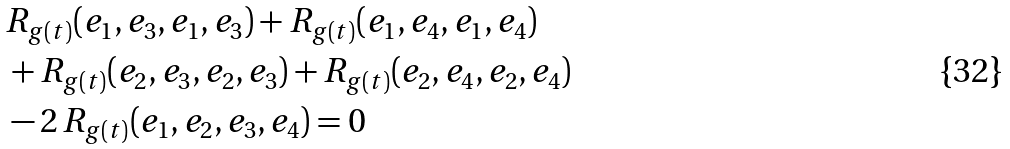Convert formula to latex. <formula><loc_0><loc_0><loc_500><loc_500>& R _ { g ( t ) } ( e _ { 1 } , e _ { 3 } , e _ { 1 } , e _ { 3 } ) + R _ { g ( t ) } ( e _ { 1 } , e _ { 4 } , e _ { 1 } , e _ { 4 } ) \\ & + R _ { g ( t ) } ( e _ { 2 } , e _ { 3 } , e _ { 2 } , e _ { 3 } ) + R _ { g ( t ) } ( e _ { 2 } , e _ { 4 } , e _ { 2 } , e _ { 4 } ) \\ & - 2 \, R _ { g ( t ) } ( e _ { 1 } , e _ { 2 } , e _ { 3 } , e _ { 4 } ) = 0</formula> 